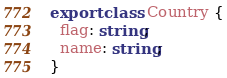Convert code to text. <code><loc_0><loc_0><loc_500><loc_500><_TypeScript_>
export class Country {
  flag: string;
  name: string;
}
</code> 